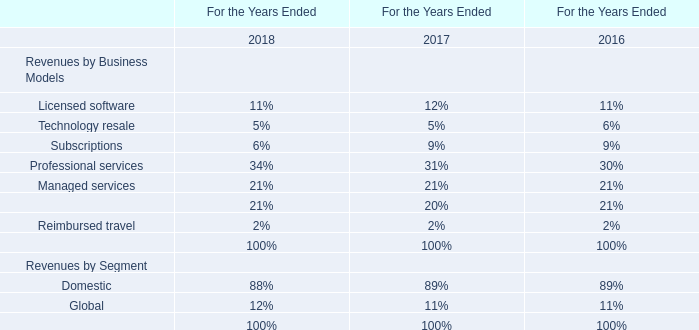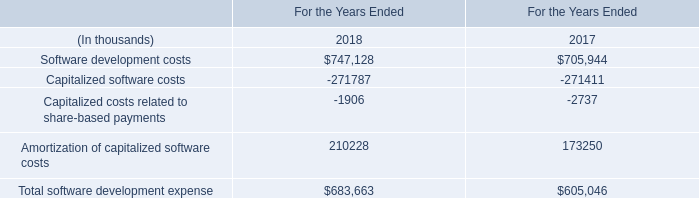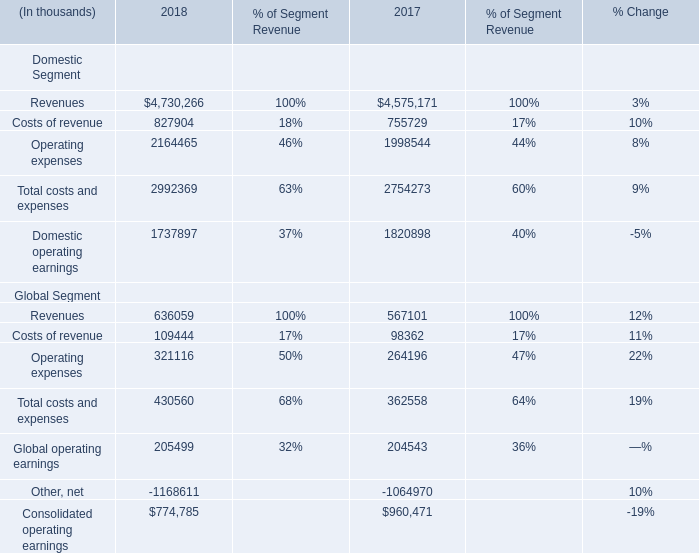what is the expected percentage change in contributions related to qualified defined benefit pension plans in 2013 compare to 2012? 
Computations: ((1.5 - 3.6) / 3.6)
Answer: -0.58333. 